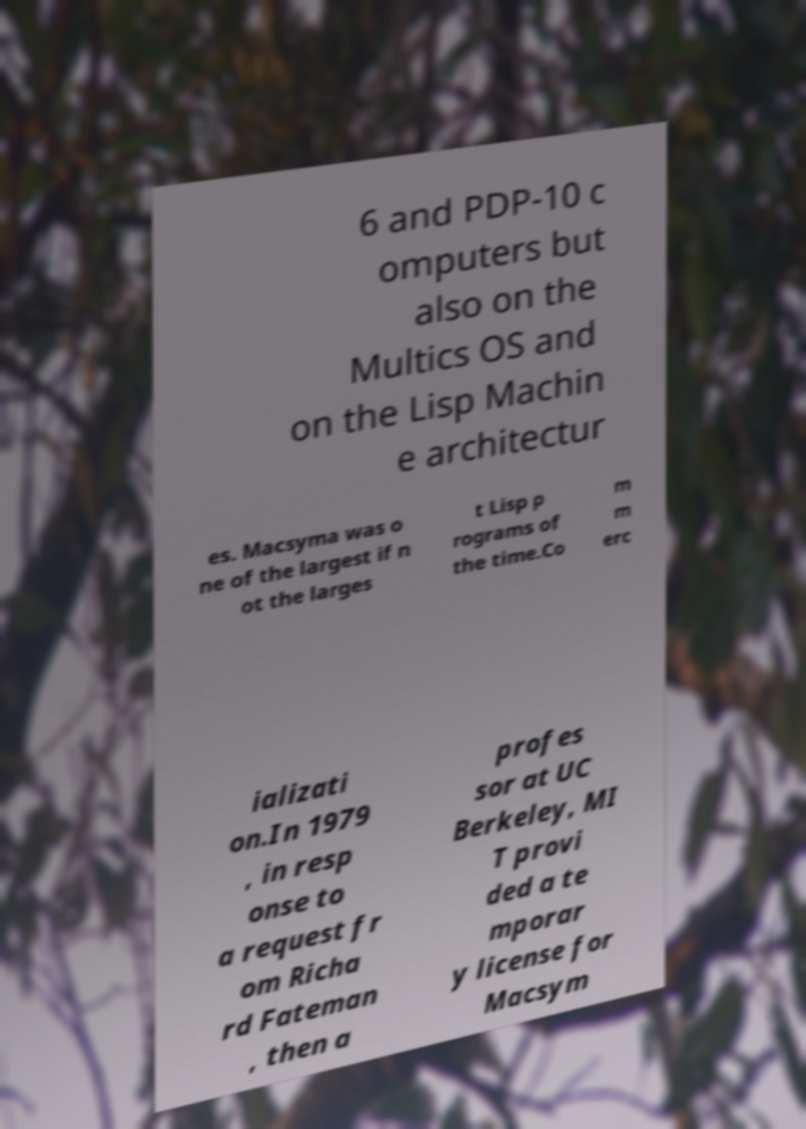What messages or text are displayed in this image? I need them in a readable, typed format. 6 and PDP-10 c omputers but also on the Multics OS and on the Lisp Machin e architectur es. Macsyma was o ne of the largest if n ot the larges t Lisp p rograms of the time.Co m m erc ializati on.In 1979 , in resp onse to a request fr om Richa rd Fateman , then a profes sor at UC Berkeley, MI T provi ded a te mporar y license for Macsym 